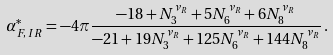Convert formula to latex. <formula><loc_0><loc_0><loc_500><loc_500>\alpha ^ { * } _ { F , \, I R } = - 4 \pi \frac { - 1 8 + N ^ { \nu _ { R } } _ { 3 } + 5 N ^ { \nu _ { R } } _ { 6 } + 6 N ^ { \nu _ { R } } _ { 8 } } { - 2 1 + 1 9 N ^ { \nu _ { R } } _ { 3 } + 1 2 5 N ^ { \nu _ { R } } _ { 6 } + 1 4 4 N ^ { \nu _ { R } } _ { 8 } } \, .</formula> 